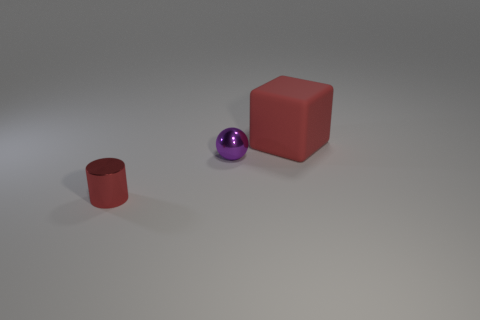Are there any other things that are the same size as the red rubber object?
Your answer should be very brief. No. Is there anything else that is the same material as the big object?
Ensure brevity in your answer.  No. Is there anything else of the same color as the metallic ball?
Make the answer very short. No. Is the shape of the big red thing the same as the tiny red thing?
Provide a succinct answer. No. There is a red thing to the left of the red thing behind the red thing that is in front of the big red thing; what size is it?
Give a very brief answer. Small. What number of other objects are the same material as the big thing?
Ensure brevity in your answer.  0. The shiny object in front of the tiny purple ball is what color?
Offer a very short reply. Red. What is the material of the red object in front of the large cube that is on the right side of the shiny object that is right of the small red cylinder?
Your answer should be very brief. Metal. Are there any other big things that have the same shape as the large object?
Provide a succinct answer. No. There is a object that is the same size as the cylinder; what shape is it?
Your response must be concise. Sphere. 